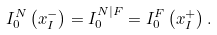<formula> <loc_0><loc_0><loc_500><loc_500>I _ { 0 } ^ { N } \left ( x _ { I } ^ { - } \right ) = I _ { 0 } ^ { N | F } = I _ { 0 } ^ { F } \left ( x _ { I } ^ { + } \right ) .</formula> 